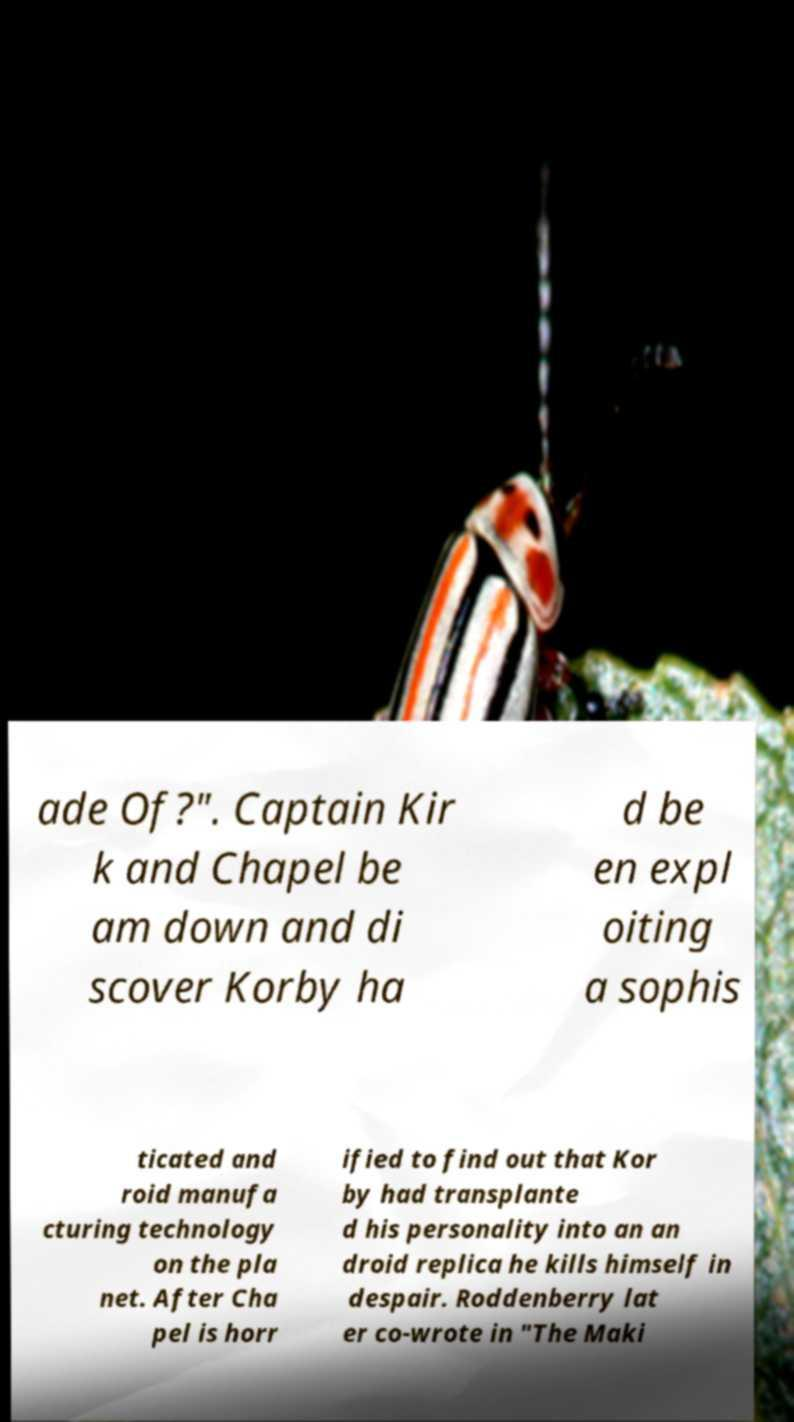There's text embedded in this image that I need extracted. Can you transcribe it verbatim? ade Of?". Captain Kir k and Chapel be am down and di scover Korby ha d be en expl oiting a sophis ticated and roid manufa cturing technology on the pla net. After Cha pel is horr ified to find out that Kor by had transplante d his personality into an an droid replica he kills himself in despair. Roddenberry lat er co-wrote in "The Maki 